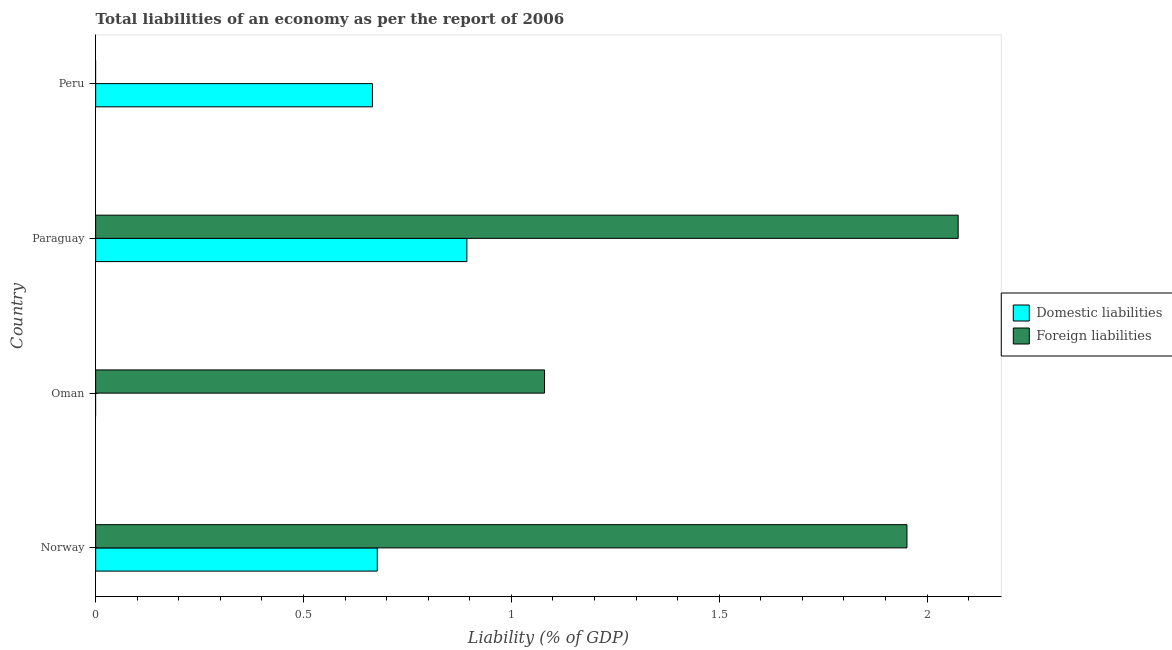Are the number of bars per tick equal to the number of legend labels?
Ensure brevity in your answer.  No. Are the number of bars on each tick of the Y-axis equal?
Your answer should be very brief. No. What is the label of the 2nd group of bars from the top?
Provide a succinct answer. Paraguay. In how many cases, is the number of bars for a given country not equal to the number of legend labels?
Offer a very short reply. 2. What is the incurrence of domestic liabilities in Peru?
Your answer should be very brief. 0.67. Across all countries, what is the maximum incurrence of domestic liabilities?
Offer a terse response. 0.89. Across all countries, what is the minimum incurrence of foreign liabilities?
Offer a terse response. 0. In which country was the incurrence of foreign liabilities maximum?
Your answer should be very brief. Paraguay. What is the total incurrence of foreign liabilities in the graph?
Your response must be concise. 5.11. What is the difference between the incurrence of domestic liabilities in Paraguay and that in Peru?
Your answer should be compact. 0.23. What is the difference between the incurrence of domestic liabilities in Paraguay and the incurrence of foreign liabilities in Oman?
Provide a short and direct response. -0.19. What is the average incurrence of foreign liabilities per country?
Your response must be concise. 1.28. What is the difference between the incurrence of domestic liabilities and incurrence of foreign liabilities in Paraguay?
Make the answer very short. -1.18. In how many countries, is the incurrence of foreign liabilities greater than 0.30000000000000004 %?
Provide a succinct answer. 3. What is the ratio of the incurrence of foreign liabilities in Norway to that in Paraguay?
Offer a very short reply. 0.94. Is the incurrence of foreign liabilities in Norway less than that in Paraguay?
Offer a very short reply. Yes. Is the difference between the incurrence of domestic liabilities in Norway and Paraguay greater than the difference between the incurrence of foreign liabilities in Norway and Paraguay?
Provide a succinct answer. No. What is the difference between the highest and the second highest incurrence of domestic liabilities?
Provide a succinct answer. 0.22. What is the difference between the highest and the lowest incurrence of foreign liabilities?
Provide a succinct answer. 2.07. In how many countries, is the incurrence of foreign liabilities greater than the average incurrence of foreign liabilities taken over all countries?
Give a very brief answer. 2. Is the sum of the incurrence of foreign liabilities in Norway and Oman greater than the maximum incurrence of domestic liabilities across all countries?
Make the answer very short. Yes. How many bars are there?
Make the answer very short. 6. How many countries are there in the graph?
Ensure brevity in your answer.  4. What is the difference between two consecutive major ticks on the X-axis?
Ensure brevity in your answer.  0.5. Does the graph contain grids?
Offer a terse response. No. Where does the legend appear in the graph?
Give a very brief answer. Center right. How many legend labels are there?
Give a very brief answer. 2. How are the legend labels stacked?
Keep it short and to the point. Vertical. What is the title of the graph?
Provide a short and direct response. Total liabilities of an economy as per the report of 2006. What is the label or title of the X-axis?
Your response must be concise. Liability (% of GDP). What is the Liability (% of GDP) in Domestic liabilities in Norway?
Your response must be concise. 0.68. What is the Liability (% of GDP) in Foreign liabilities in Norway?
Provide a succinct answer. 1.95. What is the Liability (% of GDP) in Foreign liabilities in Oman?
Make the answer very short. 1.08. What is the Liability (% of GDP) in Domestic liabilities in Paraguay?
Your response must be concise. 0.89. What is the Liability (% of GDP) of Foreign liabilities in Paraguay?
Provide a short and direct response. 2.07. What is the Liability (% of GDP) of Domestic liabilities in Peru?
Ensure brevity in your answer.  0.67. Across all countries, what is the maximum Liability (% of GDP) of Domestic liabilities?
Provide a succinct answer. 0.89. Across all countries, what is the maximum Liability (% of GDP) of Foreign liabilities?
Give a very brief answer. 2.07. Across all countries, what is the minimum Liability (% of GDP) in Domestic liabilities?
Provide a succinct answer. 0. Across all countries, what is the minimum Liability (% of GDP) in Foreign liabilities?
Ensure brevity in your answer.  0. What is the total Liability (% of GDP) of Domestic liabilities in the graph?
Make the answer very short. 2.24. What is the total Liability (% of GDP) of Foreign liabilities in the graph?
Ensure brevity in your answer.  5.11. What is the difference between the Liability (% of GDP) in Foreign liabilities in Norway and that in Oman?
Give a very brief answer. 0.87. What is the difference between the Liability (% of GDP) in Domestic liabilities in Norway and that in Paraguay?
Your response must be concise. -0.22. What is the difference between the Liability (% of GDP) in Foreign liabilities in Norway and that in Paraguay?
Provide a short and direct response. -0.12. What is the difference between the Liability (% of GDP) of Domestic liabilities in Norway and that in Peru?
Offer a very short reply. 0.01. What is the difference between the Liability (% of GDP) in Foreign liabilities in Oman and that in Paraguay?
Make the answer very short. -0.99. What is the difference between the Liability (% of GDP) of Domestic liabilities in Paraguay and that in Peru?
Your response must be concise. 0.23. What is the difference between the Liability (% of GDP) of Domestic liabilities in Norway and the Liability (% of GDP) of Foreign liabilities in Oman?
Your answer should be very brief. -0.4. What is the difference between the Liability (% of GDP) in Domestic liabilities in Norway and the Liability (% of GDP) in Foreign liabilities in Paraguay?
Keep it short and to the point. -1.4. What is the average Liability (% of GDP) in Domestic liabilities per country?
Your response must be concise. 0.56. What is the average Liability (% of GDP) of Foreign liabilities per country?
Make the answer very short. 1.28. What is the difference between the Liability (% of GDP) in Domestic liabilities and Liability (% of GDP) in Foreign liabilities in Norway?
Keep it short and to the point. -1.27. What is the difference between the Liability (% of GDP) in Domestic liabilities and Liability (% of GDP) in Foreign liabilities in Paraguay?
Offer a very short reply. -1.18. What is the ratio of the Liability (% of GDP) of Foreign liabilities in Norway to that in Oman?
Ensure brevity in your answer.  1.81. What is the ratio of the Liability (% of GDP) of Domestic liabilities in Norway to that in Paraguay?
Keep it short and to the point. 0.76. What is the ratio of the Liability (% of GDP) in Foreign liabilities in Norway to that in Paraguay?
Offer a terse response. 0.94. What is the ratio of the Liability (% of GDP) in Domestic liabilities in Norway to that in Peru?
Offer a very short reply. 1.02. What is the ratio of the Liability (% of GDP) of Foreign liabilities in Oman to that in Paraguay?
Ensure brevity in your answer.  0.52. What is the ratio of the Liability (% of GDP) of Domestic liabilities in Paraguay to that in Peru?
Give a very brief answer. 1.34. What is the difference between the highest and the second highest Liability (% of GDP) of Domestic liabilities?
Offer a terse response. 0.22. What is the difference between the highest and the second highest Liability (% of GDP) of Foreign liabilities?
Provide a succinct answer. 0.12. What is the difference between the highest and the lowest Liability (% of GDP) of Domestic liabilities?
Make the answer very short. 0.89. What is the difference between the highest and the lowest Liability (% of GDP) in Foreign liabilities?
Provide a short and direct response. 2.07. 